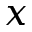<formula> <loc_0><loc_0><loc_500><loc_500>x</formula> 